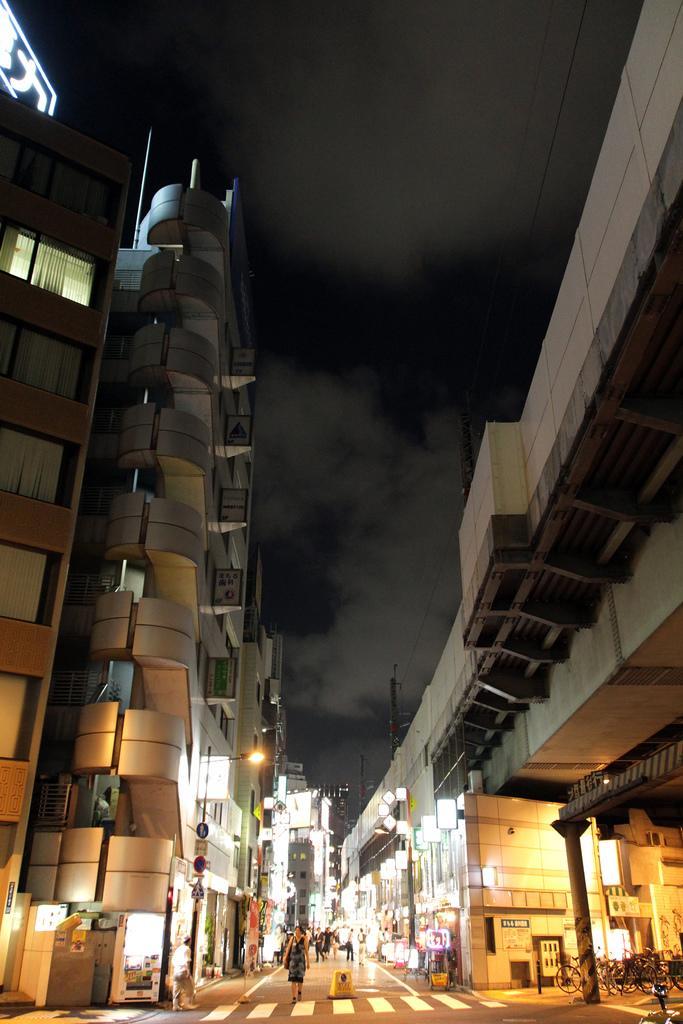Please provide a concise description of this image. In this picture we can see buildings on the right side and left side, there are some people here, on the right bottom we can see bicycles, there are some lights, poles and boards here, there is the sky at the top of the picture, we can see a pillar here. 